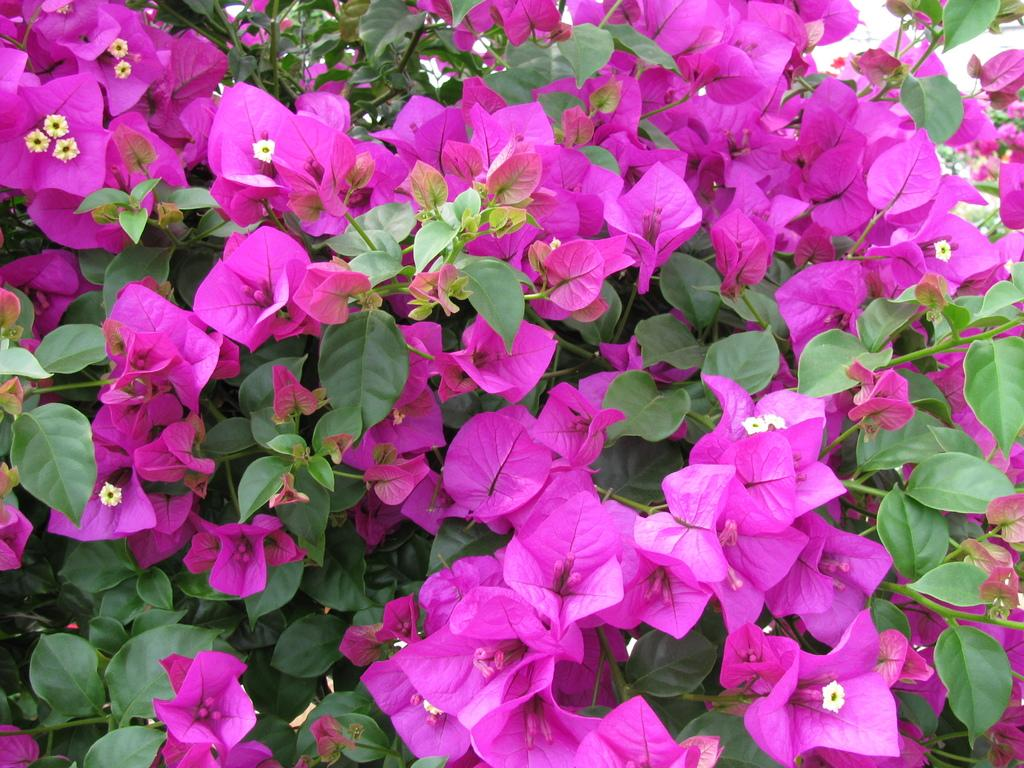What type of living organisms can be seen in the image? Plants can be seen in the image. What color are the flowers on the plants? The flowers on the plants are pink. Where is the playground located in the image? There is no playground present in the image; it features plants with pink flowers. What type of loss is depicted in the image? There is no loss depicted in the image; it features plants with pink flowers. 